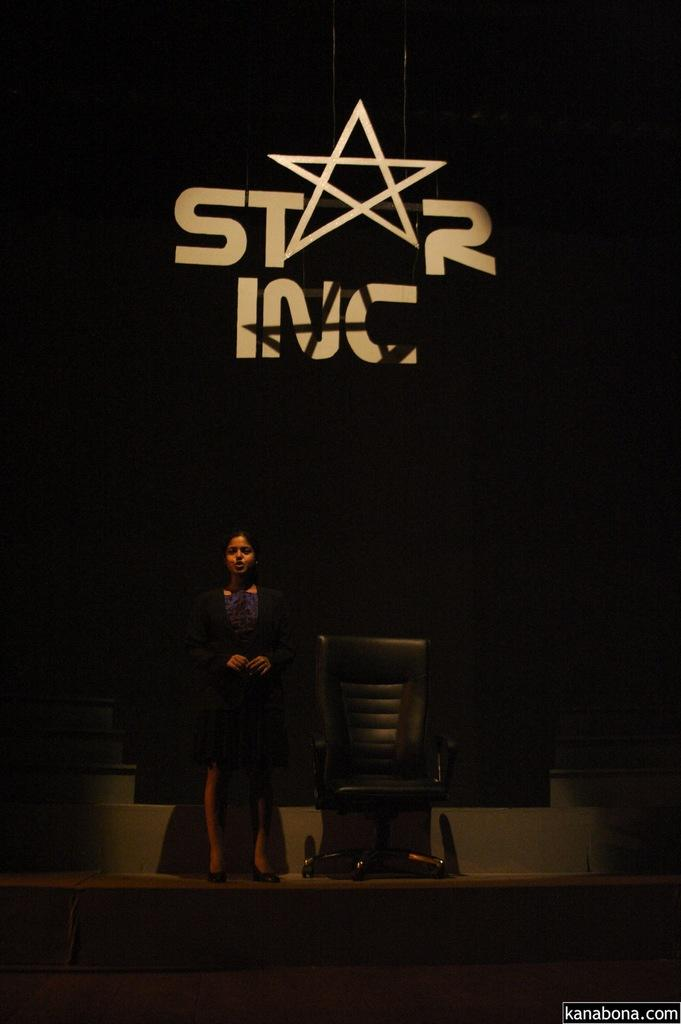What is the main subject of the image? There is a woman standing in the image. What object can be seen near the woman? There is a chair in the image. What is visible in the background behind the woman? There is a hoarding visible behind the woman. What is the color of the background in the image? The background of the image is black. Can you hear the cub playing in the background of the image? There is no mention of a cub or any sound in the image, so it cannot be determined if a cub is playing in the background. 